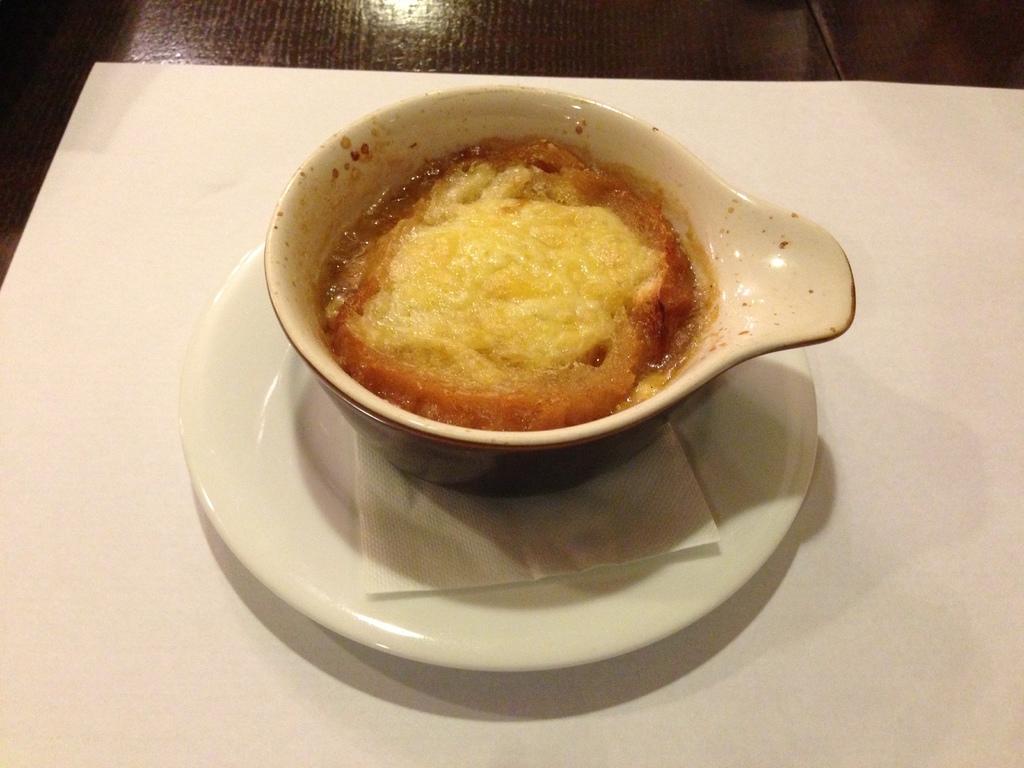How would you summarize this image in a sentence or two? In this picture we can see cup with food, plate and tissue paper on the table and we can see floor. 